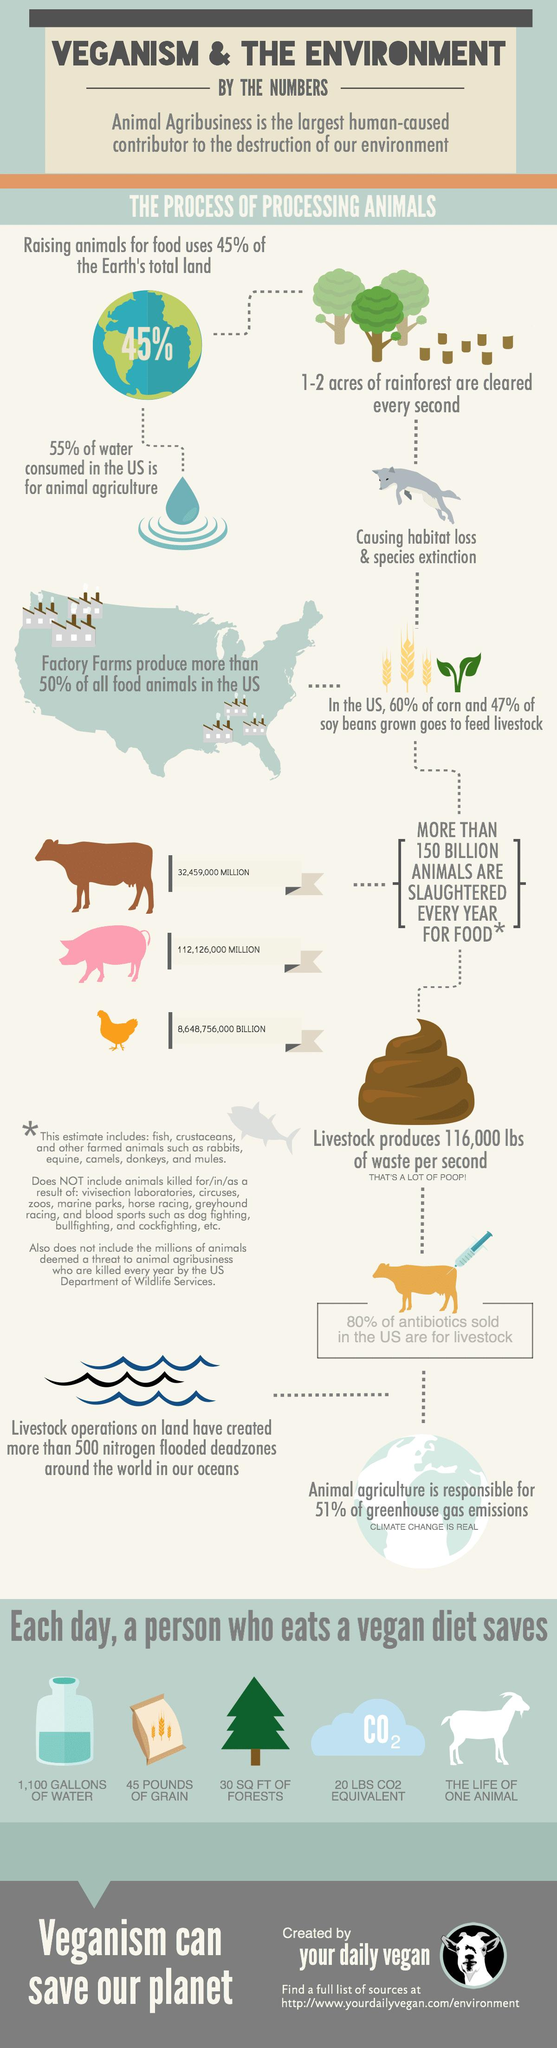Identify some key points in this picture. A vegan saves 45 pounds of grain per day by not consuming animal products. A vegan saves approximately 20 pounds of carbon dioxide per day, compared to a meat-eater, by consuming fewer resources and producing fewer greenhouse gases. On average, a vegan saves 30 square feet of forest per day by avoiding products derived from animals and their environments. Each year, an estimated 32,459,000 cattle are killed for food globally. In a year, approximately 8,648,756,000 chickens are killed for food. 